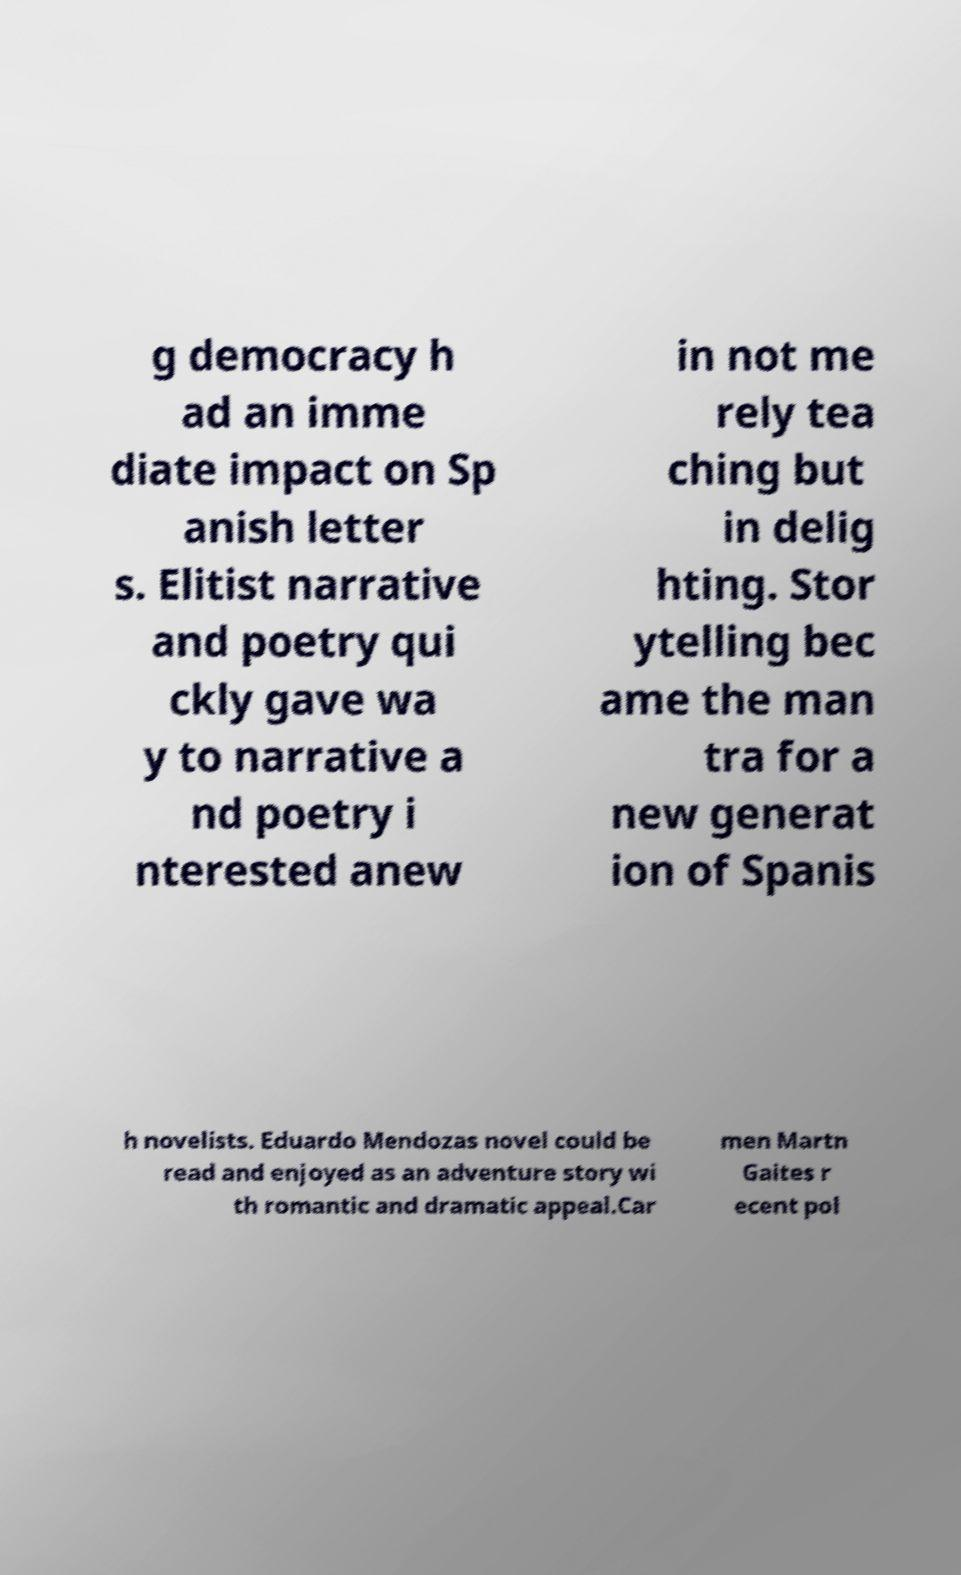For documentation purposes, I need the text within this image transcribed. Could you provide that? g democracy h ad an imme diate impact on Sp anish letter s. Elitist narrative and poetry qui ckly gave wa y to narrative a nd poetry i nterested anew in not me rely tea ching but in delig hting. Stor ytelling bec ame the man tra for a new generat ion of Spanis h novelists. Eduardo Mendozas novel could be read and enjoyed as an adventure story wi th romantic and dramatic appeal.Car men Martn Gaites r ecent pol 